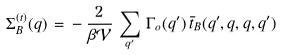<formula> <loc_0><loc_0><loc_500><loc_500>\Sigma _ { B } ^ { ( t ) } ( q ) \, = \, - \, \frac { 2 } { \beta { \mathcal { V } } } \, \sum _ { q ^ { \prime } } \, \Gamma _ { o } ( q ^ { \prime } ) \, \bar { t } _ { B } ( q ^ { \prime } , q , q , q ^ { \prime } )</formula> 